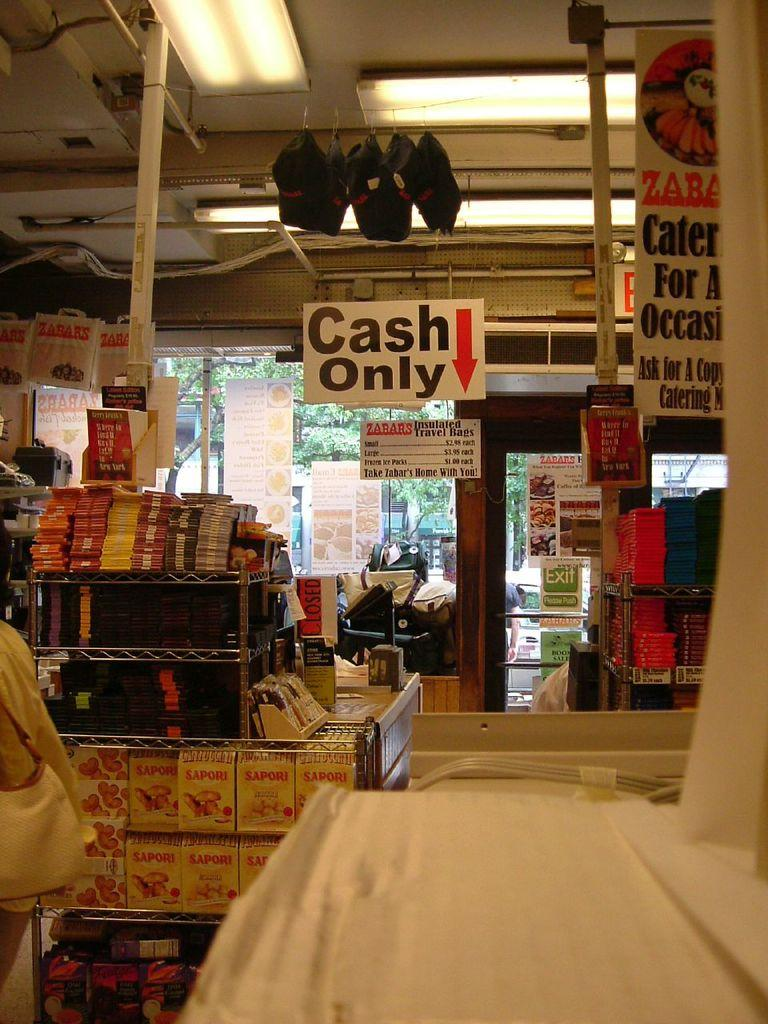<image>
Share a concise interpretation of the image provided. the inside of a store with a sign up top that says 'cash only' 